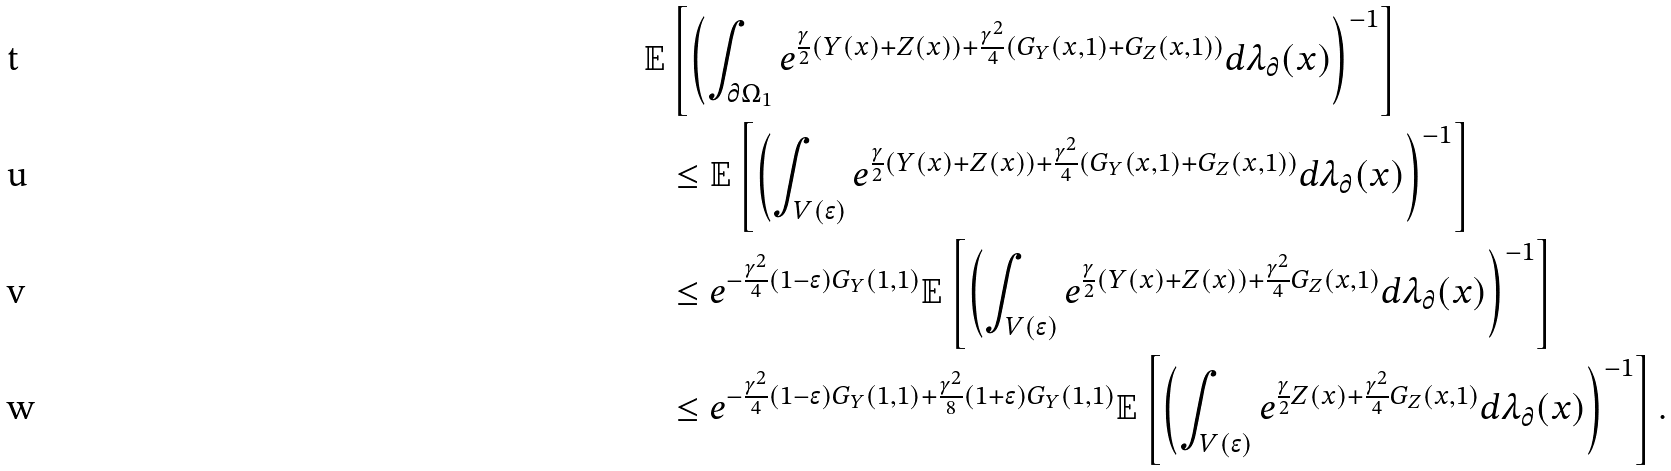Convert formula to latex. <formula><loc_0><loc_0><loc_500><loc_500>\mathbb { E } & \left [ \left ( \int _ { \partial \Omega _ { 1 } } e ^ { \frac { \gamma } { 2 } ( Y ( x ) + Z ( x ) ) + \frac { \gamma ^ { 2 } } { 4 } ( G _ { Y } ( x , 1 ) + G _ { Z } ( x , 1 ) ) } d \lambda _ { \partial } ( x ) \right ) ^ { - 1 } \right ] \\ & \leq \mathbb { E } \left [ \left ( \int _ { V ( \epsilon ) } e ^ { \frac { \gamma } { 2 } ( Y ( x ) + Z ( x ) ) + \frac { \gamma ^ { 2 } } { 4 } ( G _ { Y } ( x , 1 ) + G _ { Z } ( x , 1 ) ) } d \lambda _ { \partial } ( x ) \right ) ^ { - 1 } \right ] \\ & \leq e ^ { - \frac { \gamma ^ { 2 } } { 4 } ( 1 - \epsilon ) G _ { Y } ( 1 , 1 ) } \mathbb { E } \left [ \left ( \int _ { V ( \epsilon ) } e ^ { \frac { \gamma } { 2 } ( Y ( x ) + Z ( x ) ) + \frac { \gamma ^ { 2 } } { 4 } G _ { Z } ( x , 1 ) } d \lambda _ { \partial } ( x ) \right ) ^ { - 1 } \right ] \\ & \leq e ^ { - \frac { \gamma ^ { 2 } } { 4 } ( 1 - \epsilon ) G _ { Y } ( 1 , 1 ) + \frac { \gamma ^ { 2 } } { 8 } ( 1 + \epsilon ) G _ { Y } ( 1 , 1 ) } \mathbb { E } \left [ \left ( \int _ { V ( \epsilon ) } e ^ { \frac { \gamma } { 2 } Z ( x ) + \frac { \gamma ^ { 2 } } { 4 } G _ { Z } ( x , 1 ) } d \lambda _ { \partial } ( x ) \right ) ^ { - 1 } \right ] .</formula> 